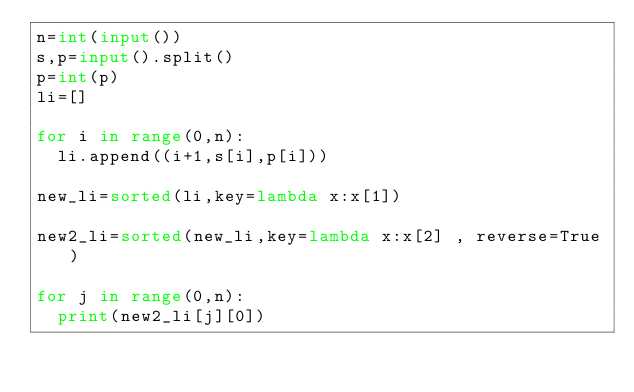Convert code to text. <code><loc_0><loc_0><loc_500><loc_500><_Python_>n=int(input())
s,p=input().split()
p=int(p)
li=[]

for i in range(0,n):
  li.append((i+1,s[i],p[i]))

new_li=sorted(li,key=lambda x:x[1])

new2_li=sorted(new_li,key=lambda x:x[2] , reverse=True)

for j in range(0,n):
  print(new2_li[j][0])
</code> 